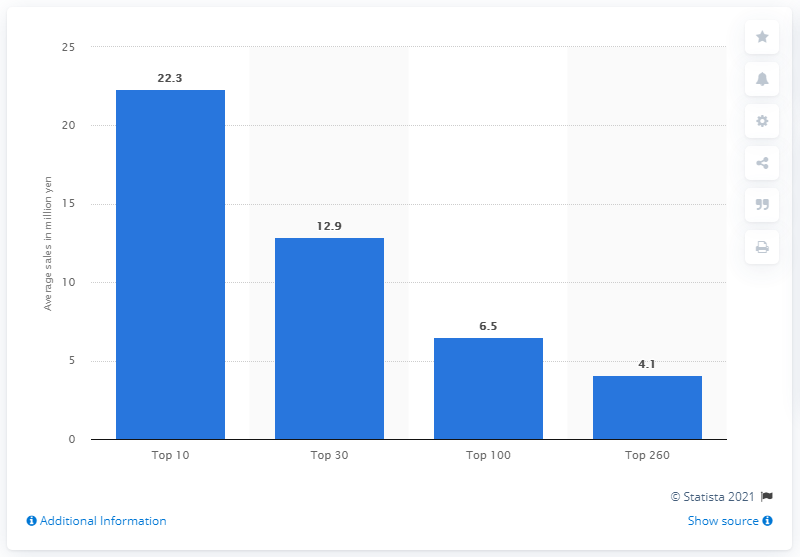Highlight a few significant elements in this photo. The average sales generated by the top 100 sticker sets was 6.5. As of August 2014, the average sales of the top ten sticker sets was 22.3. 